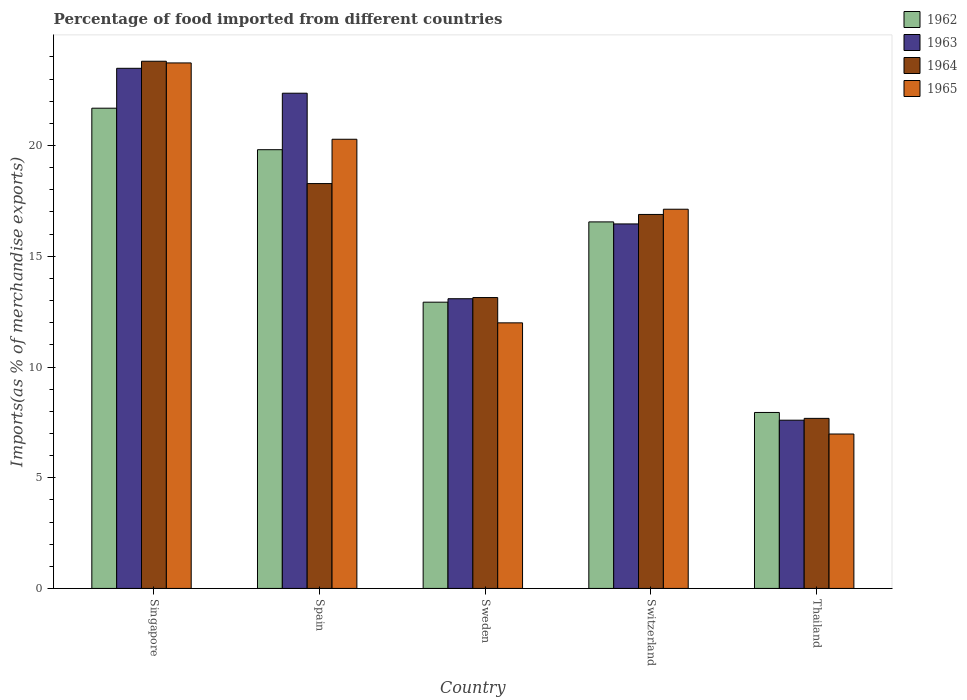How many different coloured bars are there?
Make the answer very short. 4. Are the number of bars per tick equal to the number of legend labels?
Keep it short and to the point. Yes. Are the number of bars on each tick of the X-axis equal?
Offer a very short reply. Yes. How many bars are there on the 2nd tick from the right?
Your answer should be very brief. 4. What is the label of the 5th group of bars from the left?
Your answer should be very brief. Thailand. In how many cases, is the number of bars for a given country not equal to the number of legend labels?
Your answer should be very brief. 0. What is the percentage of imports to different countries in 1962 in Switzerland?
Ensure brevity in your answer.  16.55. Across all countries, what is the maximum percentage of imports to different countries in 1964?
Provide a short and direct response. 23.81. Across all countries, what is the minimum percentage of imports to different countries in 1962?
Provide a succinct answer. 7.95. In which country was the percentage of imports to different countries in 1964 maximum?
Provide a succinct answer. Singapore. In which country was the percentage of imports to different countries in 1962 minimum?
Give a very brief answer. Thailand. What is the total percentage of imports to different countries in 1964 in the graph?
Offer a very short reply. 79.8. What is the difference between the percentage of imports to different countries in 1963 in Singapore and that in Switzerland?
Make the answer very short. 7.03. What is the difference between the percentage of imports to different countries in 1964 in Switzerland and the percentage of imports to different countries in 1962 in Spain?
Offer a terse response. -2.92. What is the average percentage of imports to different countries in 1965 per country?
Give a very brief answer. 16.02. What is the difference between the percentage of imports to different countries of/in 1965 and percentage of imports to different countries of/in 1964 in Singapore?
Your answer should be compact. -0.08. What is the ratio of the percentage of imports to different countries in 1965 in Switzerland to that in Thailand?
Your answer should be compact. 2.46. Is the difference between the percentage of imports to different countries in 1965 in Sweden and Switzerland greater than the difference between the percentage of imports to different countries in 1964 in Sweden and Switzerland?
Ensure brevity in your answer.  No. What is the difference between the highest and the second highest percentage of imports to different countries in 1962?
Provide a short and direct response. -3.26. What is the difference between the highest and the lowest percentage of imports to different countries in 1964?
Make the answer very short. 16.13. In how many countries, is the percentage of imports to different countries in 1962 greater than the average percentage of imports to different countries in 1962 taken over all countries?
Keep it short and to the point. 3. Is it the case that in every country, the sum of the percentage of imports to different countries in 1963 and percentage of imports to different countries in 1965 is greater than the sum of percentage of imports to different countries in 1962 and percentage of imports to different countries in 1964?
Ensure brevity in your answer.  No. What does the 4th bar from the left in Switzerland represents?
Your response must be concise. 1965. Is it the case that in every country, the sum of the percentage of imports to different countries in 1962 and percentage of imports to different countries in 1964 is greater than the percentage of imports to different countries in 1965?
Make the answer very short. Yes. Does the graph contain grids?
Offer a very short reply. No. Where does the legend appear in the graph?
Your response must be concise. Top right. How are the legend labels stacked?
Offer a terse response. Vertical. What is the title of the graph?
Make the answer very short. Percentage of food imported from different countries. Does "1992" appear as one of the legend labels in the graph?
Provide a short and direct response. No. What is the label or title of the Y-axis?
Give a very brief answer. Imports(as % of merchandise exports). What is the Imports(as % of merchandise exports) in 1962 in Singapore?
Your answer should be very brief. 21.69. What is the Imports(as % of merchandise exports) in 1963 in Singapore?
Provide a short and direct response. 23.49. What is the Imports(as % of merchandise exports) in 1964 in Singapore?
Your response must be concise. 23.81. What is the Imports(as % of merchandise exports) of 1965 in Singapore?
Your answer should be very brief. 23.73. What is the Imports(as % of merchandise exports) of 1962 in Spain?
Offer a very short reply. 19.81. What is the Imports(as % of merchandise exports) of 1963 in Spain?
Provide a short and direct response. 22.36. What is the Imports(as % of merchandise exports) of 1964 in Spain?
Make the answer very short. 18.28. What is the Imports(as % of merchandise exports) of 1965 in Spain?
Your answer should be very brief. 20.28. What is the Imports(as % of merchandise exports) in 1962 in Sweden?
Ensure brevity in your answer.  12.93. What is the Imports(as % of merchandise exports) in 1963 in Sweden?
Give a very brief answer. 13.08. What is the Imports(as % of merchandise exports) of 1964 in Sweden?
Ensure brevity in your answer.  13.14. What is the Imports(as % of merchandise exports) in 1965 in Sweden?
Your answer should be compact. 11.99. What is the Imports(as % of merchandise exports) of 1962 in Switzerland?
Your answer should be very brief. 16.55. What is the Imports(as % of merchandise exports) of 1963 in Switzerland?
Give a very brief answer. 16.46. What is the Imports(as % of merchandise exports) of 1964 in Switzerland?
Your answer should be very brief. 16.89. What is the Imports(as % of merchandise exports) of 1965 in Switzerland?
Your response must be concise. 17.12. What is the Imports(as % of merchandise exports) of 1962 in Thailand?
Make the answer very short. 7.95. What is the Imports(as % of merchandise exports) in 1963 in Thailand?
Your answer should be very brief. 7.6. What is the Imports(as % of merchandise exports) of 1964 in Thailand?
Your answer should be compact. 7.68. What is the Imports(as % of merchandise exports) of 1965 in Thailand?
Your answer should be compact. 6.97. Across all countries, what is the maximum Imports(as % of merchandise exports) in 1962?
Keep it short and to the point. 21.69. Across all countries, what is the maximum Imports(as % of merchandise exports) of 1963?
Offer a very short reply. 23.49. Across all countries, what is the maximum Imports(as % of merchandise exports) of 1964?
Your answer should be compact. 23.81. Across all countries, what is the maximum Imports(as % of merchandise exports) of 1965?
Keep it short and to the point. 23.73. Across all countries, what is the minimum Imports(as % of merchandise exports) of 1962?
Make the answer very short. 7.95. Across all countries, what is the minimum Imports(as % of merchandise exports) in 1963?
Your answer should be very brief. 7.6. Across all countries, what is the minimum Imports(as % of merchandise exports) in 1964?
Your answer should be very brief. 7.68. Across all countries, what is the minimum Imports(as % of merchandise exports) of 1965?
Your response must be concise. 6.97. What is the total Imports(as % of merchandise exports) in 1962 in the graph?
Your response must be concise. 78.93. What is the total Imports(as % of merchandise exports) of 1963 in the graph?
Your answer should be compact. 83. What is the total Imports(as % of merchandise exports) in 1964 in the graph?
Provide a short and direct response. 79.8. What is the total Imports(as % of merchandise exports) in 1965 in the graph?
Offer a very short reply. 80.11. What is the difference between the Imports(as % of merchandise exports) in 1962 in Singapore and that in Spain?
Your response must be concise. 1.87. What is the difference between the Imports(as % of merchandise exports) in 1963 in Singapore and that in Spain?
Provide a succinct answer. 1.12. What is the difference between the Imports(as % of merchandise exports) in 1964 in Singapore and that in Spain?
Your response must be concise. 5.52. What is the difference between the Imports(as % of merchandise exports) in 1965 in Singapore and that in Spain?
Ensure brevity in your answer.  3.45. What is the difference between the Imports(as % of merchandise exports) of 1962 in Singapore and that in Sweden?
Provide a short and direct response. 8.76. What is the difference between the Imports(as % of merchandise exports) in 1963 in Singapore and that in Sweden?
Provide a succinct answer. 10.41. What is the difference between the Imports(as % of merchandise exports) of 1964 in Singapore and that in Sweden?
Offer a very short reply. 10.67. What is the difference between the Imports(as % of merchandise exports) of 1965 in Singapore and that in Sweden?
Your answer should be compact. 11.74. What is the difference between the Imports(as % of merchandise exports) of 1962 in Singapore and that in Switzerland?
Provide a short and direct response. 5.13. What is the difference between the Imports(as % of merchandise exports) of 1963 in Singapore and that in Switzerland?
Ensure brevity in your answer.  7.03. What is the difference between the Imports(as % of merchandise exports) in 1964 in Singapore and that in Switzerland?
Make the answer very short. 6.92. What is the difference between the Imports(as % of merchandise exports) of 1965 in Singapore and that in Switzerland?
Your answer should be very brief. 6.61. What is the difference between the Imports(as % of merchandise exports) in 1962 in Singapore and that in Thailand?
Provide a short and direct response. 13.74. What is the difference between the Imports(as % of merchandise exports) of 1963 in Singapore and that in Thailand?
Give a very brief answer. 15.89. What is the difference between the Imports(as % of merchandise exports) of 1964 in Singapore and that in Thailand?
Provide a short and direct response. 16.13. What is the difference between the Imports(as % of merchandise exports) in 1965 in Singapore and that in Thailand?
Keep it short and to the point. 16.76. What is the difference between the Imports(as % of merchandise exports) in 1962 in Spain and that in Sweden?
Provide a short and direct response. 6.89. What is the difference between the Imports(as % of merchandise exports) of 1963 in Spain and that in Sweden?
Give a very brief answer. 9.28. What is the difference between the Imports(as % of merchandise exports) of 1964 in Spain and that in Sweden?
Your answer should be very brief. 5.15. What is the difference between the Imports(as % of merchandise exports) of 1965 in Spain and that in Sweden?
Your answer should be compact. 8.29. What is the difference between the Imports(as % of merchandise exports) in 1962 in Spain and that in Switzerland?
Make the answer very short. 3.26. What is the difference between the Imports(as % of merchandise exports) of 1963 in Spain and that in Switzerland?
Provide a short and direct response. 5.9. What is the difference between the Imports(as % of merchandise exports) in 1964 in Spain and that in Switzerland?
Your answer should be very brief. 1.39. What is the difference between the Imports(as % of merchandise exports) of 1965 in Spain and that in Switzerland?
Ensure brevity in your answer.  3.16. What is the difference between the Imports(as % of merchandise exports) of 1962 in Spain and that in Thailand?
Your response must be concise. 11.87. What is the difference between the Imports(as % of merchandise exports) of 1963 in Spain and that in Thailand?
Ensure brevity in your answer.  14.77. What is the difference between the Imports(as % of merchandise exports) in 1964 in Spain and that in Thailand?
Your answer should be compact. 10.6. What is the difference between the Imports(as % of merchandise exports) in 1965 in Spain and that in Thailand?
Offer a terse response. 13.31. What is the difference between the Imports(as % of merchandise exports) of 1962 in Sweden and that in Switzerland?
Keep it short and to the point. -3.63. What is the difference between the Imports(as % of merchandise exports) of 1963 in Sweden and that in Switzerland?
Ensure brevity in your answer.  -3.38. What is the difference between the Imports(as % of merchandise exports) in 1964 in Sweden and that in Switzerland?
Give a very brief answer. -3.75. What is the difference between the Imports(as % of merchandise exports) in 1965 in Sweden and that in Switzerland?
Ensure brevity in your answer.  -5.13. What is the difference between the Imports(as % of merchandise exports) of 1962 in Sweden and that in Thailand?
Offer a very short reply. 4.98. What is the difference between the Imports(as % of merchandise exports) of 1963 in Sweden and that in Thailand?
Offer a very short reply. 5.49. What is the difference between the Imports(as % of merchandise exports) in 1964 in Sweden and that in Thailand?
Offer a terse response. 5.46. What is the difference between the Imports(as % of merchandise exports) of 1965 in Sweden and that in Thailand?
Provide a succinct answer. 5.02. What is the difference between the Imports(as % of merchandise exports) of 1962 in Switzerland and that in Thailand?
Give a very brief answer. 8.61. What is the difference between the Imports(as % of merchandise exports) in 1963 in Switzerland and that in Thailand?
Offer a very short reply. 8.86. What is the difference between the Imports(as % of merchandise exports) in 1964 in Switzerland and that in Thailand?
Your answer should be compact. 9.21. What is the difference between the Imports(as % of merchandise exports) in 1965 in Switzerland and that in Thailand?
Your answer should be compact. 10.15. What is the difference between the Imports(as % of merchandise exports) of 1962 in Singapore and the Imports(as % of merchandise exports) of 1963 in Spain?
Give a very brief answer. -0.68. What is the difference between the Imports(as % of merchandise exports) in 1962 in Singapore and the Imports(as % of merchandise exports) in 1964 in Spain?
Make the answer very short. 3.4. What is the difference between the Imports(as % of merchandise exports) of 1962 in Singapore and the Imports(as % of merchandise exports) of 1965 in Spain?
Your answer should be very brief. 1.4. What is the difference between the Imports(as % of merchandise exports) of 1963 in Singapore and the Imports(as % of merchandise exports) of 1964 in Spain?
Your response must be concise. 5.21. What is the difference between the Imports(as % of merchandise exports) of 1963 in Singapore and the Imports(as % of merchandise exports) of 1965 in Spain?
Offer a terse response. 3.2. What is the difference between the Imports(as % of merchandise exports) in 1964 in Singapore and the Imports(as % of merchandise exports) in 1965 in Spain?
Provide a short and direct response. 3.52. What is the difference between the Imports(as % of merchandise exports) in 1962 in Singapore and the Imports(as % of merchandise exports) in 1963 in Sweden?
Provide a succinct answer. 8.6. What is the difference between the Imports(as % of merchandise exports) in 1962 in Singapore and the Imports(as % of merchandise exports) in 1964 in Sweden?
Ensure brevity in your answer.  8.55. What is the difference between the Imports(as % of merchandise exports) of 1962 in Singapore and the Imports(as % of merchandise exports) of 1965 in Sweden?
Provide a short and direct response. 9.69. What is the difference between the Imports(as % of merchandise exports) of 1963 in Singapore and the Imports(as % of merchandise exports) of 1964 in Sweden?
Give a very brief answer. 10.35. What is the difference between the Imports(as % of merchandise exports) of 1963 in Singapore and the Imports(as % of merchandise exports) of 1965 in Sweden?
Provide a short and direct response. 11.5. What is the difference between the Imports(as % of merchandise exports) in 1964 in Singapore and the Imports(as % of merchandise exports) in 1965 in Sweden?
Provide a short and direct response. 11.81. What is the difference between the Imports(as % of merchandise exports) of 1962 in Singapore and the Imports(as % of merchandise exports) of 1963 in Switzerland?
Provide a short and direct response. 5.23. What is the difference between the Imports(as % of merchandise exports) of 1962 in Singapore and the Imports(as % of merchandise exports) of 1964 in Switzerland?
Provide a succinct answer. 4.8. What is the difference between the Imports(as % of merchandise exports) in 1962 in Singapore and the Imports(as % of merchandise exports) in 1965 in Switzerland?
Give a very brief answer. 4.56. What is the difference between the Imports(as % of merchandise exports) of 1963 in Singapore and the Imports(as % of merchandise exports) of 1964 in Switzerland?
Keep it short and to the point. 6.6. What is the difference between the Imports(as % of merchandise exports) in 1963 in Singapore and the Imports(as % of merchandise exports) in 1965 in Switzerland?
Your answer should be very brief. 6.36. What is the difference between the Imports(as % of merchandise exports) in 1964 in Singapore and the Imports(as % of merchandise exports) in 1965 in Switzerland?
Provide a succinct answer. 6.68. What is the difference between the Imports(as % of merchandise exports) of 1962 in Singapore and the Imports(as % of merchandise exports) of 1963 in Thailand?
Offer a terse response. 14.09. What is the difference between the Imports(as % of merchandise exports) of 1962 in Singapore and the Imports(as % of merchandise exports) of 1964 in Thailand?
Offer a very short reply. 14.01. What is the difference between the Imports(as % of merchandise exports) of 1962 in Singapore and the Imports(as % of merchandise exports) of 1965 in Thailand?
Make the answer very short. 14.71. What is the difference between the Imports(as % of merchandise exports) in 1963 in Singapore and the Imports(as % of merchandise exports) in 1964 in Thailand?
Your answer should be very brief. 15.81. What is the difference between the Imports(as % of merchandise exports) of 1963 in Singapore and the Imports(as % of merchandise exports) of 1965 in Thailand?
Ensure brevity in your answer.  16.52. What is the difference between the Imports(as % of merchandise exports) in 1964 in Singapore and the Imports(as % of merchandise exports) in 1965 in Thailand?
Make the answer very short. 16.83. What is the difference between the Imports(as % of merchandise exports) in 1962 in Spain and the Imports(as % of merchandise exports) in 1963 in Sweden?
Keep it short and to the point. 6.73. What is the difference between the Imports(as % of merchandise exports) in 1962 in Spain and the Imports(as % of merchandise exports) in 1964 in Sweden?
Provide a short and direct response. 6.68. What is the difference between the Imports(as % of merchandise exports) in 1962 in Spain and the Imports(as % of merchandise exports) in 1965 in Sweden?
Your response must be concise. 7.82. What is the difference between the Imports(as % of merchandise exports) in 1963 in Spain and the Imports(as % of merchandise exports) in 1964 in Sweden?
Make the answer very short. 9.23. What is the difference between the Imports(as % of merchandise exports) of 1963 in Spain and the Imports(as % of merchandise exports) of 1965 in Sweden?
Your answer should be compact. 10.37. What is the difference between the Imports(as % of merchandise exports) in 1964 in Spain and the Imports(as % of merchandise exports) in 1965 in Sweden?
Your answer should be compact. 6.29. What is the difference between the Imports(as % of merchandise exports) of 1962 in Spain and the Imports(as % of merchandise exports) of 1963 in Switzerland?
Your answer should be compact. 3.35. What is the difference between the Imports(as % of merchandise exports) of 1962 in Spain and the Imports(as % of merchandise exports) of 1964 in Switzerland?
Keep it short and to the point. 2.92. What is the difference between the Imports(as % of merchandise exports) of 1962 in Spain and the Imports(as % of merchandise exports) of 1965 in Switzerland?
Ensure brevity in your answer.  2.69. What is the difference between the Imports(as % of merchandise exports) of 1963 in Spain and the Imports(as % of merchandise exports) of 1964 in Switzerland?
Your response must be concise. 5.48. What is the difference between the Imports(as % of merchandise exports) of 1963 in Spain and the Imports(as % of merchandise exports) of 1965 in Switzerland?
Your response must be concise. 5.24. What is the difference between the Imports(as % of merchandise exports) of 1964 in Spain and the Imports(as % of merchandise exports) of 1965 in Switzerland?
Make the answer very short. 1.16. What is the difference between the Imports(as % of merchandise exports) of 1962 in Spain and the Imports(as % of merchandise exports) of 1963 in Thailand?
Offer a very short reply. 12.22. What is the difference between the Imports(as % of merchandise exports) in 1962 in Spain and the Imports(as % of merchandise exports) in 1964 in Thailand?
Keep it short and to the point. 12.13. What is the difference between the Imports(as % of merchandise exports) of 1962 in Spain and the Imports(as % of merchandise exports) of 1965 in Thailand?
Provide a short and direct response. 12.84. What is the difference between the Imports(as % of merchandise exports) in 1963 in Spain and the Imports(as % of merchandise exports) in 1964 in Thailand?
Provide a succinct answer. 14.68. What is the difference between the Imports(as % of merchandise exports) in 1963 in Spain and the Imports(as % of merchandise exports) in 1965 in Thailand?
Ensure brevity in your answer.  15.39. What is the difference between the Imports(as % of merchandise exports) of 1964 in Spain and the Imports(as % of merchandise exports) of 1965 in Thailand?
Keep it short and to the point. 11.31. What is the difference between the Imports(as % of merchandise exports) of 1962 in Sweden and the Imports(as % of merchandise exports) of 1963 in Switzerland?
Provide a succinct answer. -3.53. What is the difference between the Imports(as % of merchandise exports) in 1962 in Sweden and the Imports(as % of merchandise exports) in 1964 in Switzerland?
Keep it short and to the point. -3.96. What is the difference between the Imports(as % of merchandise exports) in 1962 in Sweden and the Imports(as % of merchandise exports) in 1965 in Switzerland?
Offer a very short reply. -4.2. What is the difference between the Imports(as % of merchandise exports) in 1963 in Sweden and the Imports(as % of merchandise exports) in 1964 in Switzerland?
Your response must be concise. -3.81. What is the difference between the Imports(as % of merchandise exports) of 1963 in Sweden and the Imports(as % of merchandise exports) of 1965 in Switzerland?
Your answer should be compact. -4.04. What is the difference between the Imports(as % of merchandise exports) in 1964 in Sweden and the Imports(as % of merchandise exports) in 1965 in Switzerland?
Ensure brevity in your answer.  -3.99. What is the difference between the Imports(as % of merchandise exports) in 1962 in Sweden and the Imports(as % of merchandise exports) in 1963 in Thailand?
Ensure brevity in your answer.  5.33. What is the difference between the Imports(as % of merchandise exports) of 1962 in Sweden and the Imports(as % of merchandise exports) of 1964 in Thailand?
Ensure brevity in your answer.  5.25. What is the difference between the Imports(as % of merchandise exports) of 1962 in Sweden and the Imports(as % of merchandise exports) of 1965 in Thailand?
Your answer should be very brief. 5.95. What is the difference between the Imports(as % of merchandise exports) in 1963 in Sweden and the Imports(as % of merchandise exports) in 1964 in Thailand?
Your answer should be compact. 5.4. What is the difference between the Imports(as % of merchandise exports) of 1963 in Sweden and the Imports(as % of merchandise exports) of 1965 in Thailand?
Ensure brevity in your answer.  6.11. What is the difference between the Imports(as % of merchandise exports) of 1964 in Sweden and the Imports(as % of merchandise exports) of 1965 in Thailand?
Provide a succinct answer. 6.16. What is the difference between the Imports(as % of merchandise exports) of 1962 in Switzerland and the Imports(as % of merchandise exports) of 1963 in Thailand?
Offer a terse response. 8.96. What is the difference between the Imports(as % of merchandise exports) of 1962 in Switzerland and the Imports(as % of merchandise exports) of 1964 in Thailand?
Provide a succinct answer. 8.87. What is the difference between the Imports(as % of merchandise exports) in 1962 in Switzerland and the Imports(as % of merchandise exports) in 1965 in Thailand?
Make the answer very short. 9.58. What is the difference between the Imports(as % of merchandise exports) of 1963 in Switzerland and the Imports(as % of merchandise exports) of 1964 in Thailand?
Make the answer very short. 8.78. What is the difference between the Imports(as % of merchandise exports) of 1963 in Switzerland and the Imports(as % of merchandise exports) of 1965 in Thailand?
Your answer should be compact. 9.49. What is the difference between the Imports(as % of merchandise exports) of 1964 in Switzerland and the Imports(as % of merchandise exports) of 1965 in Thailand?
Your answer should be compact. 9.92. What is the average Imports(as % of merchandise exports) of 1962 per country?
Provide a short and direct response. 15.79. What is the average Imports(as % of merchandise exports) in 1963 per country?
Your response must be concise. 16.6. What is the average Imports(as % of merchandise exports) of 1964 per country?
Your answer should be compact. 15.96. What is the average Imports(as % of merchandise exports) in 1965 per country?
Provide a succinct answer. 16.02. What is the difference between the Imports(as % of merchandise exports) of 1962 and Imports(as % of merchandise exports) of 1963 in Singapore?
Give a very brief answer. -1.8. What is the difference between the Imports(as % of merchandise exports) of 1962 and Imports(as % of merchandise exports) of 1964 in Singapore?
Your answer should be very brief. -2.12. What is the difference between the Imports(as % of merchandise exports) in 1962 and Imports(as % of merchandise exports) in 1965 in Singapore?
Provide a succinct answer. -2.04. What is the difference between the Imports(as % of merchandise exports) of 1963 and Imports(as % of merchandise exports) of 1964 in Singapore?
Offer a very short reply. -0.32. What is the difference between the Imports(as % of merchandise exports) in 1963 and Imports(as % of merchandise exports) in 1965 in Singapore?
Your answer should be very brief. -0.24. What is the difference between the Imports(as % of merchandise exports) of 1964 and Imports(as % of merchandise exports) of 1965 in Singapore?
Keep it short and to the point. 0.08. What is the difference between the Imports(as % of merchandise exports) in 1962 and Imports(as % of merchandise exports) in 1963 in Spain?
Your response must be concise. -2.55. What is the difference between the Imports(as % of merchandise exports) in 1962 and Imports(as % of merchandise exports) in 1964 in Spain?
Keep it short and to the point. 1.53. What is the difference between the Imports(as % of merchandise exports) of 1962 and Imports(as % of merchandise exports) of 1965 in Spain?
Keep it short and to the point. -0.47. What is the difference between the Imports(as % of merchandise exports) of 1963 and Imports(as % of merchandise exports) of 1964 in Spain?
Give a very brief answer. 4.08. What is the difference between the Imports(as % of merchandise exports) in 1963 and Imports(as % of merchandise exports) in 1965 in Spain?
Ensure brevity in your answer.  2.08. What is the difference between the Imports(as % of merchandise exports) of 1964 and Imports(as % of merchandise exports) of 1965 in Spain?
Offer a terse response. -2. What is the difference between the Imports(as % of merchandise exports) in 1962 and Imports(as % of merchandise exports) in 1963 in Sweden?
Give a very brief answer. -0.16. What is the difference between the Imports(as % of merchandise exports) in 1962 and Imports(as % of merchandise exports) in 1964 in Sweden?
Your answer should be very brief. -0.21. What is the difference between the Imports(as % of merchandise exports) in 1962 and Imports(as % of merchandise exports) in 1965 in Sweden?
Your response must be concise. 0.93. What is the difference between the Imports(as % of merchandise exports) of 1963 and Imports(as % of merchandise exports) of 1964 in Sweden?
Offer a terse response. -0.05. What is the difference between the Imports(as % of merchandise exports) in 1963 and Imports(as % of merchandise exports) in 1965 in Sweden?
Give a very brief answer. 1.09. What is the difference between the Imports(as % of merchandise exports) in 1964 and Imports(as % of merchandise exports) in 1965 in Sweden?
Offer a very short reply. 1.14. What is the difference between the Imports(as % of merchandise exports) in 1962 and Imports(as % of merchandise exports) in 1963 in Switzerland?
Keep it short and to the point. 0.09. What is the difference between the Imports(as % of merchandise exports) in 1962 and Imports(as % of merchandise exports) in 1964 in Switzerland?
Give a very brief answer. -0.34. What is the difference between the Imports(as % of merchandise exports) of 1962 and Imports(as % of merchandise exports) of 1965 in Switzerland?
Provide a succinct answer. -0.57. What is the difference between the Imports(as % of merchandise exports) of 1963 and Imports(as % of merchandise exports) of 1964 in Switzerland?
Your answer should be very brief. -0.43. What is the difference between the Imports(as % of merchandise exports) in 1963 and Imports(as % of merchandise exports) in 1965 in Switzerland?
Provide a short and direct response. -0.66. What is the difference between the Imports(as % of merchandise exports) of 1964 and Imports(as % of merchandise exports) of 1965 in Switzerland?
Make the answer very short. -0.24. What is the difference between the Imports(as % of merchandise exports) of 1962 and Imports(as % of merchandise exports) of 1963 in Thailand?
Offer a terse response. 0.35. What is the difference between the Imports(as % of merchandise exports) in 1962 and Imports(as % of merchandise exports) in 1964 in Thailand?
Keep it short and to the point. 0.27. What is the difference between the Imports(as % of merchandise exports) of 1962 and Imports(as % of merchandise exports) of 1965 in Thailand?
Offer a very short reply. 0.97. What is the difference between the Imports(as % of merchandise exports) of 1963 and Imports(as % of merchandise exports) of 1964 in Thailand?
Offer a terse response. -0.08. What is the difference between the Imports(as % of merchandise exports) in 1963 and Imports(as % of merchandise exports) in 1965 in Thailand?
Ensure brevity in your answer.  0.62. What is the difference between the Imports(as % of merchandise exports) of 1964 and Imports(as % of merchandise exports) of 1965 in Thailand?
Your response must be concise. 0.71. What is the ratio of the Imports(as % of merchandise exports) in 1962 in Singapore to that in Spain?
Offer a terse response. 1.09. What is the ratio of the Imports(as % of merchandise exports) of 1963 in Singapore to that in Spain?
Offer a very short reply. 1.05. What is the ratio of the Imports(as % of merchandise exports) in 1964 in Singapore to that in Spain?
Your answer should be very brief. 1.3. What is the ratio of the Imports(as % of merchandise exports) in 1965 in Singapore to that in Spain?
Offer a terse response. 1.17. What is the ratio of the Imports(as % of merchandise exports) in 1962 in Singapore to that in Sweden?
Keep it short and to the point. 1.68. What is the ratio of the Imports(as % of merchandise exports) of 1963 in Singapore to that in Sweden?
Provide a short and direct response. 1.8. What is the ratio of the Imports(as % of merchandise exports) in 1964 in Singapore to that in Sweden?
Provide a short and direct response. 1.81. What is the ratio of the Imports(as % of merchandise exports) in 1965 in Singapore to that in Sweden?
Give a very brief answer. 1.98. What is the ratio of the Imports(as % of merchandise exports) of 1962 in Singapore to that in Switzerland?
Offer a very short reply. 1.31. What is the ratio of the Imports(as % of merchandise exports) in 1963 in Singapore to that in Switzerland?
Provide a succinct answer. 1.43. What is the ratio of the Imports(as % of merchandise exports) of 1964 in Singapore to that in Switzerland?
Ensure brevity in your answer.  1.41. What is the ratio of the Imports(as % of merchandise exports) of 1965 in Singapore to that in Switzerland?
Give a very brief answer. 1.39. What is the ratio of the Imports(as % of merchandise exports) in 1962 in Singapore to that in Thailand?
Give a very brief answer. 2.73. What is the ratio of the Imports(as % of merchandise exports) of 1963 in Singapore to that in Thailand?
Your answer should be compact. 3.09. What is the ratio of the Imports(as % of merchandise exports) of 1964 in Singapore to that in Thailand?
Ensure brevity in your answer.  3.1. What is the ratio of the Imports(as % of merchandise exports) in 1965 in Singapore to that in Thailand?
Give a very brief answer. 3.4. What is the ratio of the Imports(as % of merchandise exports) of 1962 in Spain to that in Sweden?
Ensure brevity in your answer.  1.53. What is the ratio of the Imports(as % of merchandise exports) in 1963 in Spain to that in Sweden?
Offer a terse response. 1.71. What is the ratio of the Imports(as % of merchandise exports) in 1964 in Spain to that in Sweden?
Your response must be concise. 1.39. What is the ratio of the Imports(as % of merchandise exports) in 1965 in Spain to that in Sweden?
Offer a terse response. 1.69. What is the ratio of the Imports(as % of merchandise exports) in 1962 in Spain to that in Switzerland?
Offer a very short reply. 1.2. What is the ratio of the Imports(as % of merchandise exports) in 1963 in Spain to that in Switzerland?
Provide a succinct answer. 1.36. What is the ratio of the Imports(as % of merchandise exports) in 1964 in Spain to that in Switzerland?
Your answer should be very brief. 1.08. What is the ratio of the Imports(as % of merchandise exports) in 1965 in Spain to that in Switzerland?
Make the answer very short. 1.18. What is the ratio of the Imports(as % of merchandise exports) in 1962 in Spain to that in Thailand?
Provide a short and direct response. 2.49. What is the ratio of the Imports(as % of merchandise exports) in 1963 in Spain to that in Thailand?
Provide a succinct answer. 2.94. What is the ratio of the Imports(as % of merchandise exports) in 1964 in Spain to that in Thailand?
Your answer should be compact. 2.38. What is the ratio of the Imports(as % of merchandise exports) in 1965 in Spain to that in Thailand?
Make the answer very short. 2.91. What is the ratio of the Imports(as % of merchandise exports) in 1962 in Sweden to that in Switzerland?
Give a very brief answer. 0.78. What is the ratio of the Imports(as % of merchandise exports) of 1963 in Sweden to that in Switzerland?
Offer a very short reply. 0.79. What is the ratio of the Imports(as % of merchandise exports) in 1964 in Sweden to that in Switzerland?
Your answer should be compact. 0.78. What is the ratio of the Imports(as % of merchandise exports) of 1965 in Sweden to that in Switzerland?
Make the answer very short. 0.7. What is the ratio of the Imports(as % of merchandise exports) in 1962 in Sweden to that in Thailand?
Your answer should be very brief. 1.63. What is the ratio of the Imports(as % of merchandise exports) of 1963 in Sweden to that in Thailand?
Offer a very short reply. 1.72. What is the ratio of the Imports(as % of merchandise exports) of 1964 in Sweden to that in Thailand?
Your answer should be compact. 1.71. What is the ratio of the Imports(as % of merchandise exports) of 1965 in Sweden to that in Thailand?
Keep it short and to the point. 1.72. What is the ratio of the Imports(as % of merchandise exports) of 1962 in Switzerland to that in Thailand?
Offer a terse response. 2.08. What is the ratio of the Imports(as % of merchandise exports) of 1963 in Switzerland to that in Thailand?
Give a very brief answer. 2.17. What is the ratio of the Imports(as % of merchandise exports) in 1964 in Switzerland to that in Thailand?
Make the answer very short. 2.2. What is the ratio of the Imports(as % of merchandise exports) of 1965 in Switzerland to that in Thailand?
Your answer should be compact. 2.46. What is the difference between the highest and the second highest Imports(as % of merchandise exports) of 1962?
Your answer should be compact. 1.87. What is the difference between the highest and the second highest Imports(as % of merchandise exports) of 1963?
Your response must be concise. 1.12. What is the difference between the highest and the second highest Imports(as % of merchandise exports) in 1964?
Offer a terse response. 5.52. What is the difference between the highest and the second highest Imports(as % of merchandise exports) of 1965?
Offer a very short reply. 3.45. What is the difference between the highest and the lowest Imports(as % of merchandise exports) of 1962?
Provide a short and direct response. 13.74. What is the difference between the highest and the lowest Imports(as % of merchandise exports) of 1963?
Your answer should be compact. 15.89. What is the difference between the highest and the lowest Imports(as % of merchandise exports) of 1964?
Your answer should be compact. 16.13. What is the difference between the highest and the lowest Imports(as % of merchandise exports) in 1965?
Provide a succinct answer. 16.76. 